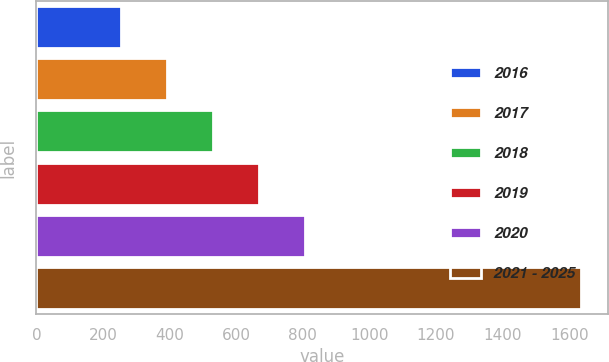Convert chart. <chart><loc_0><loc_0><loc_500><loc_500><bar_chart><fcel>2016<fcel>2017<fcel>2018<fcel>2019<fcel>2020<fcel>2021 - 2025<nl><fcel>255<fcel>393.1<fcel>531.2<fcel>669.3<fcel>807.4<fcel>1636<nl></chart> 